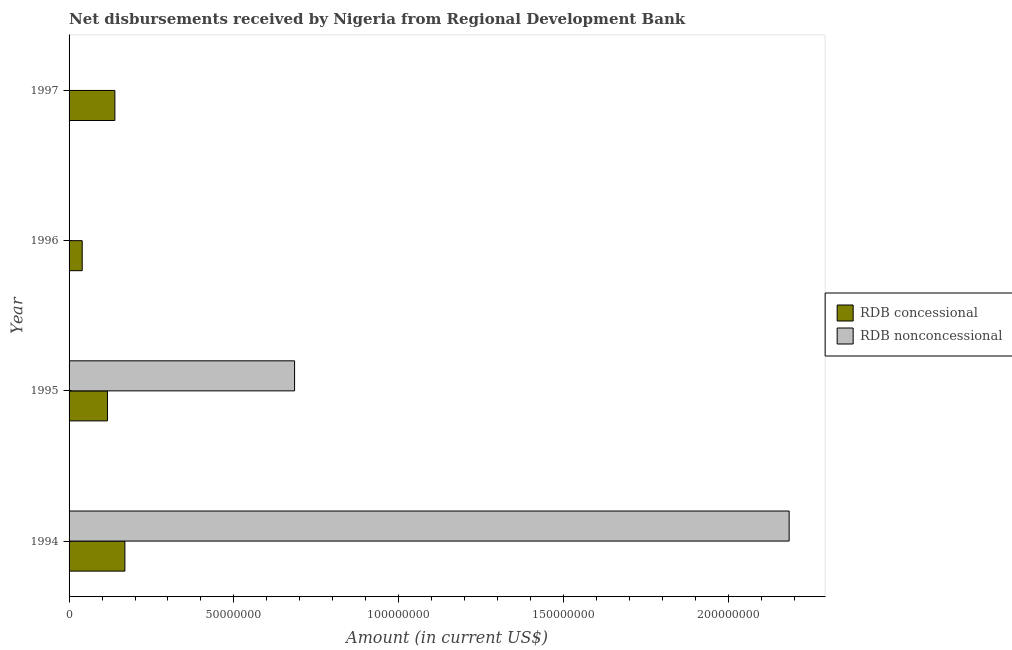How many different coloured bars are there?
Your response must be concise. 2. Are the number of bars per tick equal to the number of legend labels?
Your answer should be compact. No. Are the number of bars on each tick of the Y-axis equal?
Keep it short and to the point. No. How many bars are there on the 4th tick from the top?
Your answer should be very brief. 2. In how many cases, is the number of bars for a given year not equal to the number of legend labels?
Your response must be concise. 2. What is the net concessional disbursements from rdb in 1996?
Keep it short and to the point. 3.98e+06. Across all years, what is the maximum net concessional disbursements from rdb?
Offer a very short reply. 1.69e+07. In which year was the net concessional disbursements from rdb maximum?
Make the answer very short. 1994. What is the total net non concessional disbursements from rdb in the graph?
Your answer should be compact. 2.87e+08. What is the difference between the net concessional disbursements from rdb in 1995 and that in 1996?
Your answer should be very brief. 7.66e+06. What is the difference between the net non concessional disbursements from rdb in 1996 and the net concessional disbursements from rdb in 1995?
Provide a succinct answer. -1.16e+07. What is the average net non concessional disbursements from rdb per year?
Your answer should be very brief. 7.17e+07. In the year 1995, what is the difference between the net non concessional disbursements from rdb and net concessional disbursements from rdb?
Provide a succinct answer. 5.68e+07. In how many years, is the net concessional disbursements from rdb greater than 180000000 US$?
Your response must be concise. 0. What is the ratio of the net concessional disbursements from rdb in 1994 to that in 1997?
Offer a terse response. 1.22. What is the difference between the highest and the second highest net concessional disbursements from rdb?
Provide a short and direct response. 3.04e+06. What is the difference between the highest and the lowest net concessional disbursements from rdb?
Provide a succinct answer. 1.30e+07. Is the sum of the net concessional disbursements from rdb in 1996 and 1997 greater than the maximum net non concessional disbursements from rdb across all years?
Your answer should be compact. No. What is the difference between two consecutive major ticks on the X-axis?
Make the answer very short. 5.00e+07. Are the values on the major ticks of X-axis written in scientific E-notation?
Your answer should be compact. No. Does the graph contain any zero values?
Make the answer very short. Yes. Does the graph contain grids?
Keep it short and to the point. No. What is the title of the graph?
Your answer should be compact. Net disbursements received by Nigeria from Regional Development Bank. Does "Researchers" appear as one of the legend labels in the graph?
Give a very brief answer. No. What is the Amount (in current US$) of RDB concessional in 1994?
Give a very brief answer. 1.69e+07. What is the Amount (in current US$) of RDB nonconcessional in 1994?
Your answer should be compact. 2.18e+08. What is the Amount (in current US$) of RDB concessional in 1995?
Ensure brevity in your answer.  1.16e+07. What is the Amount (in current US$) of RDB nonconcessional in 1995?
Offer a terse response. 6.84e+07. What is the Amount (in current US$) of RDB concessional in 1996?
Provide a short and direct response. 3.98e+06. What is the Amount (in current US$) of RDB nonconcessional in 1996?
Make the answer very short. 0. What is the Amount (in current US$) in RDB concessional in 1997?
Provide a succinct answer. 1.39e+07. What is the Amount (in current US$) in RDB nonconcessional in 1997?
Provide a succinct answer. 0. Across all years, what is the maximum Amount (in current US$) in RDB concessional?
Provide a succinct answer. 1.69e+07. Across all years, what is the maximum Amount (in current US$) in RDB nonconcessional?
Offer a terse response. 2.18e+08. Across all years, what is the minimum Amount (in current US$) in RDB concessional?
Provide a short and direct response. 3.98e+06. Across all years, what is the minimum Amount (in current US$) of RDB nonconcessional?
Your answer should be compact. 0. What is the total Amount (in current US$) in RDB concessional in the graph?
Provide a succinct answer. 4.65e+07. What is the total Amount (in current US$) of RDB nonconcessional in the graph?
Ensure brevity in your answer.  2.87e+08. What is the difference between the Amount (in current US$) in RDB concessional in 1994 and that in 1995?
Your answer should be compact. 5.29e+06. What is the difference between the Amount (in current US$) in RDB nonconcessional in 1994 and that in 1995?
Make the answer very short. 1.50e+08. What is the difference between the Amount (in current US$) of RDB concessional in 1994 and that in 1996?
Offer a very short reply. 1.30e+07. What is the difference between the Amount (in current US$) of RDB concessional in 1994 and that in 1997?
Your answer should be very brief. 3.04e+06. What is the difference between the Amount (in current US$) in RDB concessional in 1995 and that in 1996?
Give a very brief answer. 7.66e+06. What is the difference between the Amount (in current US$) of RDB concessional in 1995 and that in 1997?
Ensure brevity in your answer.  -2.25e+06. What is the difference between the Amount (in current US$) in RDB concessional in 1996 and that in 1997?
Provide a short and direct response. -9.91e+06. What is the difference between the Amount (in current US$) of RDB concessional in 1994 and the Amount (in current US$) of RDB nonconcessional in 1995?
Ensure brevity in your answer.  -5.15e+07. What is the average Amount (in current US$) of RDB concessional per year?
Your answer should be compact. 1.16e+07. What is the average Amount (in current US$) in RDB nonconcessional per year?
Keep it short and to the point. 7.17e+07. In the year 1994, what is the difference between the Amount (in current US$) in RDB concessional and Amount (in current US$) in RDB nonconcessional?
Offer a very short reply. -2.02e+08. In the year 1995, what is the difference between the Amount (in current US$) of RDB concessional and Amount (in current US$) of RDB nonconcessional?
Provide a succinct answer. -5.68e+07. What is the ratio of the Amount (in current US$) of RDB concessional in 1994 to that in 1995?
Give a very brief answer. 1.45. What is the ratio of the Amount (in current US$) of RDB nonconcessional in 1994 to that in 1995?
Offer a very short reply. 3.19. What is the ratio of the Amount (in current US$) in RDB concessional in 1994 to that in 1996?
Your answer should be compact. 4.25. What is the ratio of the Amount (in current US$) of RDB concessional in 1994 to that in 1997?
Make the answer very short. 1.22. What is the ratio of the Amount (in current US$) in RDB concessional in 1995 to that in 1996?
Offer a terse response. 2.92. What is the ratio of the Amount (in current US$) of RDB concessional in 1995 to that in 1997?
Offer a terse response. 0.84. What is the ratio of the Amount (in current US$) of RDB concessional in 1996 to that in 1997?
Offer a terse response. 0.29. What is the difference between the highest and the second highest Amount (in current US$) in RDB concessional?
Provide a succinct answer. 3.04e+06. What is the difference between the highest and the lowest Amount (in current US$) in RDB concessional?
Give a very brief answer. 1.30e+07. What is the difference between the highest and the lowest Amount (in current US$) of RDB nonconcessional?
Provide a succinct answer. 2.18e+08. 